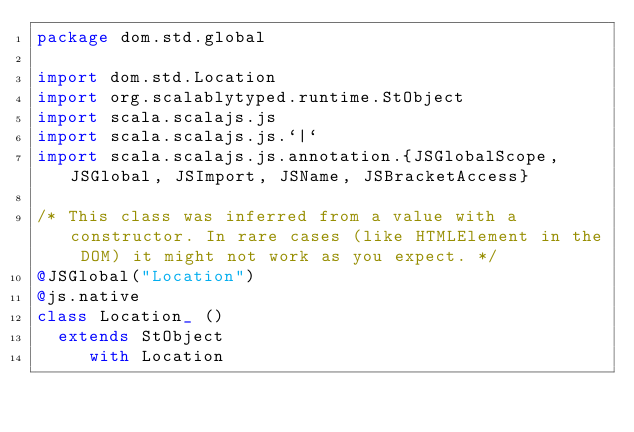Convert code to text. <code><loc_0><loc_0><loc_500><loc_500><_Scala_>package dom.std.global

import dom.std.Location
import org.scalablytyped.runtime.StObject
import scala.scalajs.js
import scala.scalajs.js.`|`
import scala.scalajs.js.annotation.{JSGlobalScope, JSGlobal, JSImport, JSName, JSBracketAccess}

/* This class was inferred from a value with a constructor. In rare cases (like HTMLElement in the DOM) it might not work as you expect. */
@JSGlobal("Location")
@js.native
class Location_ ()
  extends StObject
     with Location
</code> 